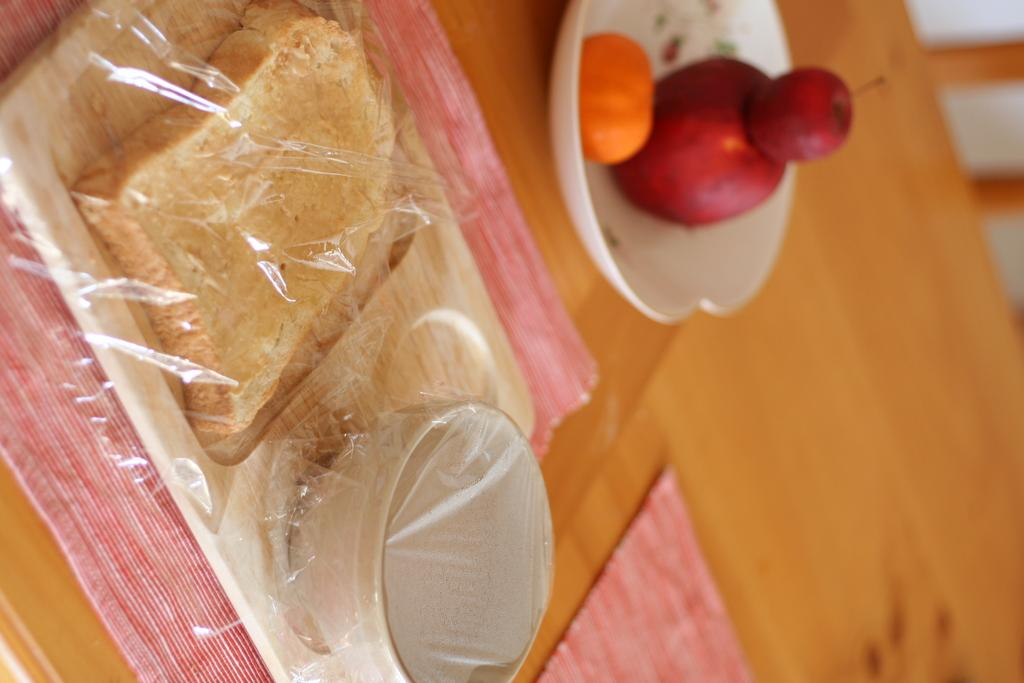What type of surface is visible in the image? There is a wooden surface in the image. What items are placed on the wooden surface? There are napkins and a bowl on the wooden surface. What is on the napkin? There is a wooden plate on one of the napkins. What is on the wooden plate? There are food items on the wooden plate. What type of food is in the bowl? There are fruits in the bowl. What type of metal design can be seen on the fruits in the image? There is no metal design present on the fruits in the image; they are simply fruits in a bowl. 